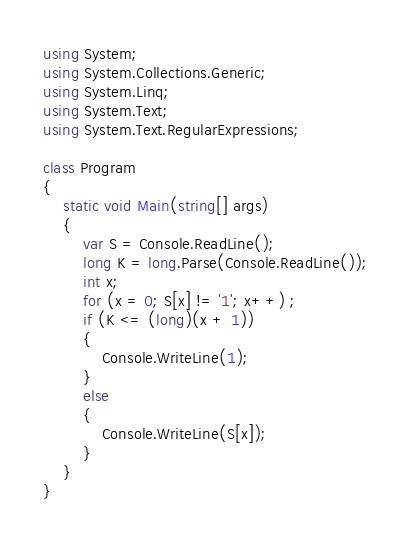<code> <loc_0><loc_0><loc_500><loc_500><_C#_>using System;
using System.Collections.Generic;
using System.Linq;
using System.Text;
using System.Text.RegularExpressions;

class Program
{
    static void Main(string[] args)
    {
        var S = Console.ReadLine();
        long K = long.Parse(Console.ReadLine());
        int x;
        for (x = 0; S[x] != '1'; x++) ;
        if (K <= (long)(x + 1))
        {
            Console.WriteLine(1);
        }
        else
        {
            Console.WriteLine(S[x]);
        }
    }
}</code> 